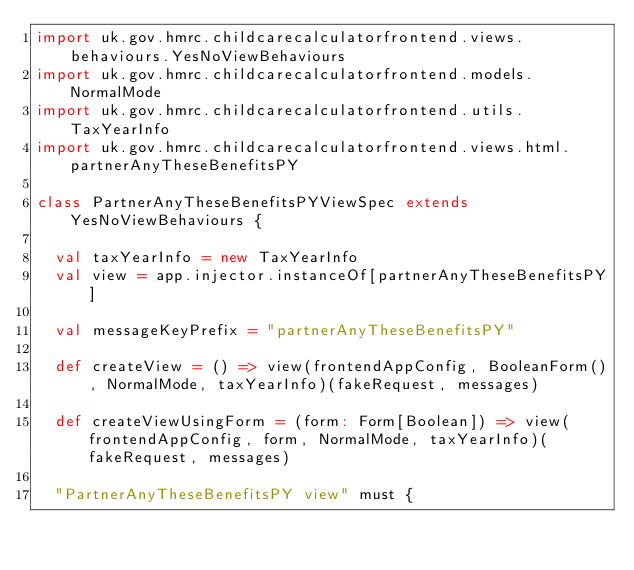<code> <loc_0><loc_0><loc_500><loc_500><_Scala_>import uk.gov.hmrc.childcarecalculatorfrontend.views.behaviours.YesNoViewBehaviours
import uk.gov.hmrc.childcarecalculatorfrontend.models.NormalMode
import uk.gov.hmrc.childcarecalculatorfrontend.utils.TaxYearInfo
import uk.gov.hmrc.childcarecalculatorfrontend.views.html.partnerAnyTheseBenefitsPY

class PartnerAnyTheseBenefitsPYViewSpec extends YesNoViewBehaviours {

  val taxYearInfo = new TaxYearInfo
  val view = app.injector.instanceOf[partnerAnyTheseBenefitsPY]

  val messageKeyPrefix = "partnerAnyTheseBenefitsPY"

  def createView = () => view(frontendAppConfig, BooleanForm(), NormalMode, taxYearInfo)(fakeRequest, messages)

  def createViewUsingForm = (form: Form[Boolean]) => view(frontendAppConfig, form, NormalMode, taxYearInfo)(fakeRequest, messages)

  "PartnerAnyTheseBenefitsPY view" must {
</code> 